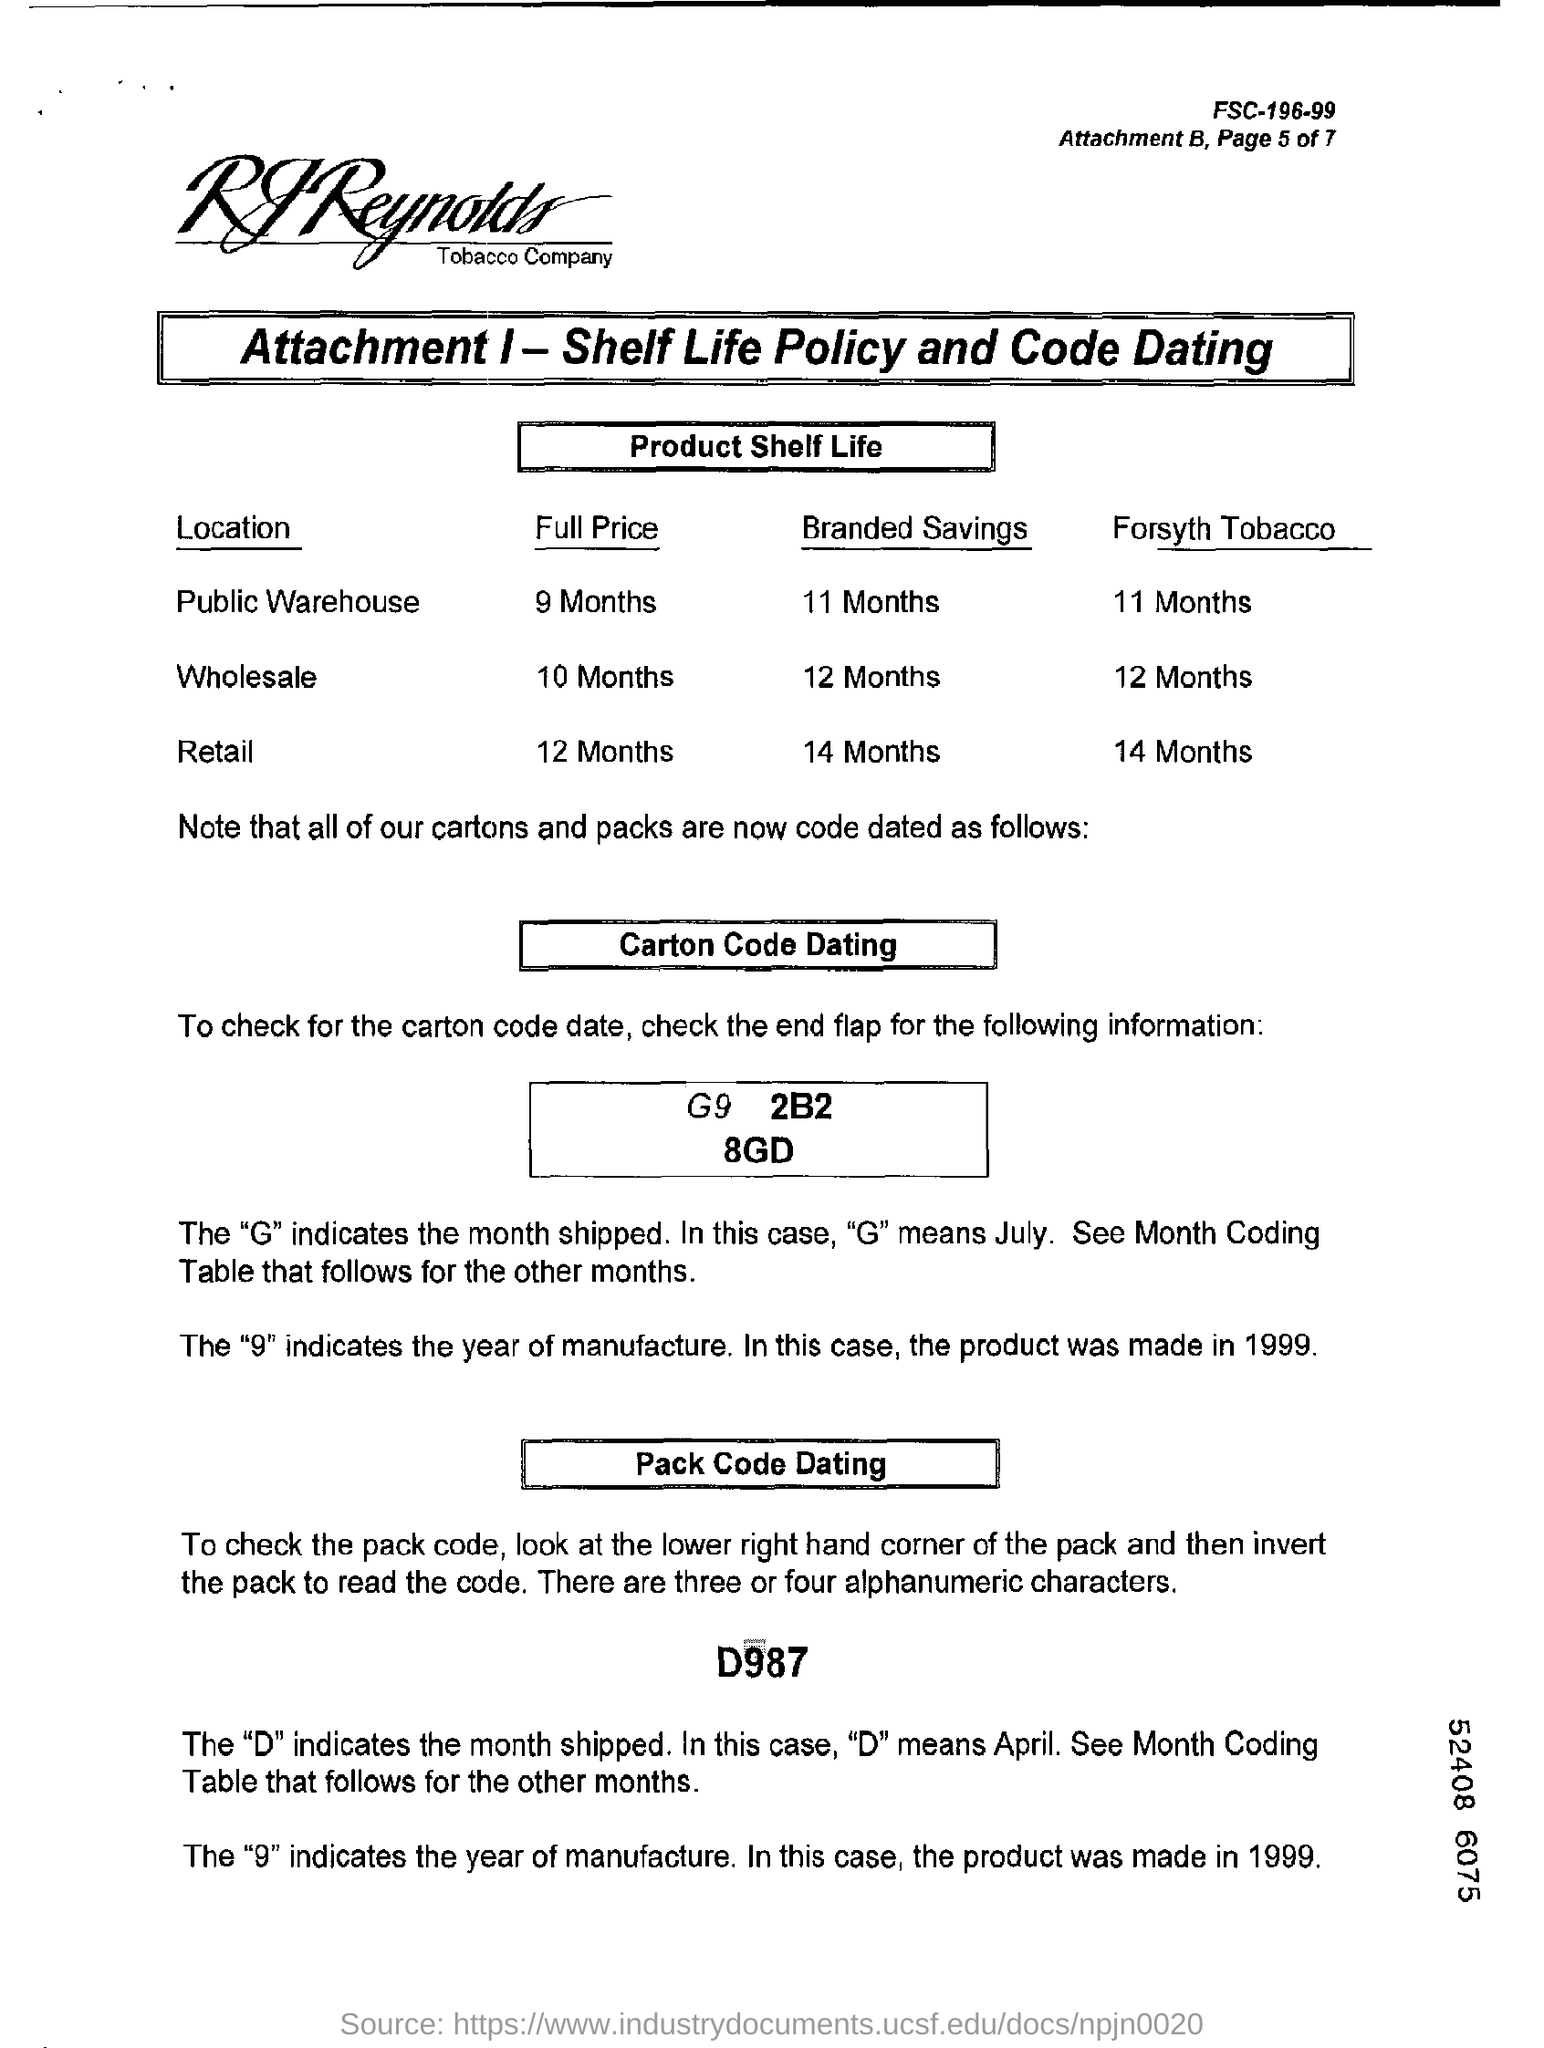What is the full price of retail ?
Provide a succinct answer. 12 Months. In D987 what does "D" indicate ?
Make the answer very short. Month shipped. What is the full price of wholesale ?
Offer a very short reply. 10 months. In D987 what does "9" indicate ?
Give a very brief answer. The year of manufacture. 